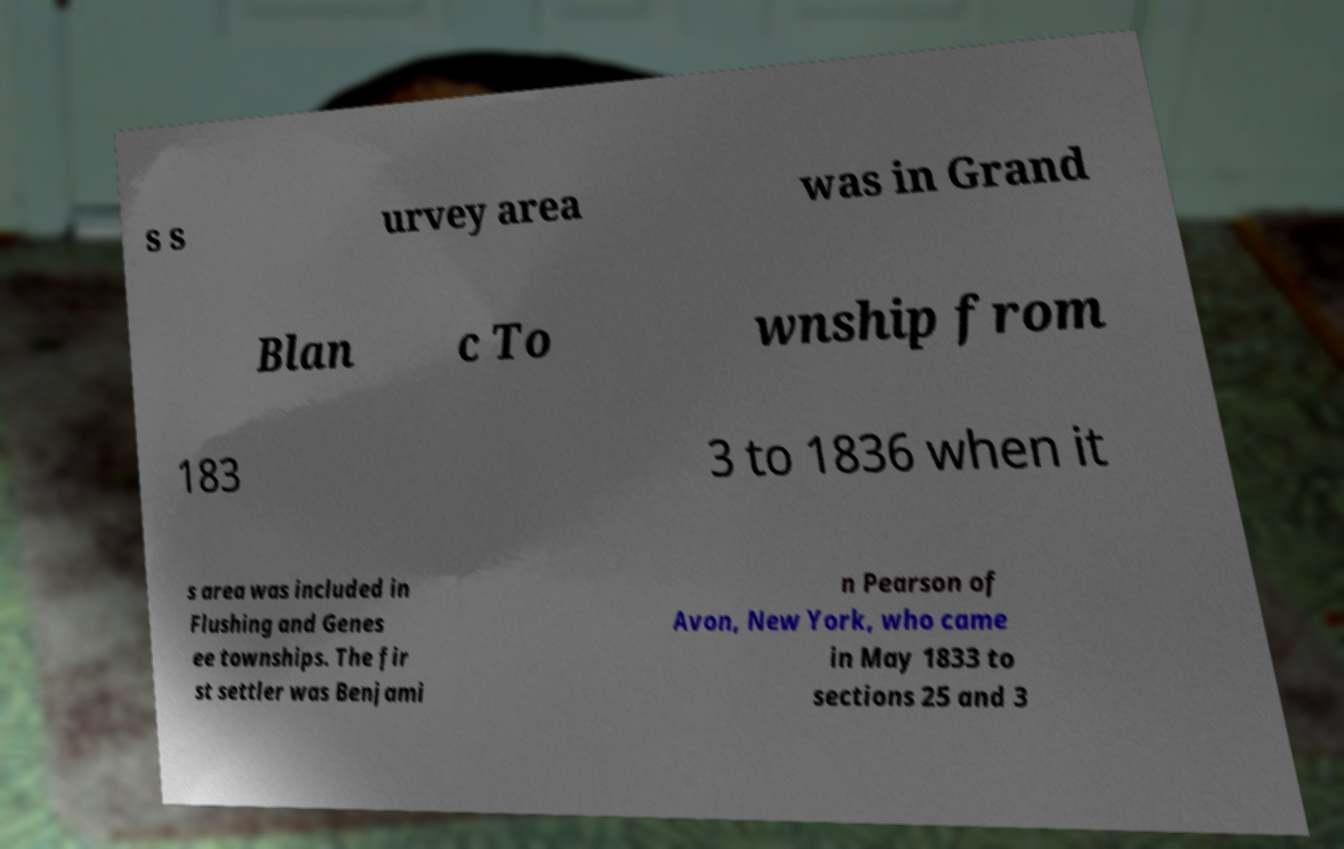Can you read and provide the text displayed in the image?This photo seems to have some interesting text. Can you extract and type it out for me? s s urvey area was in Grand Blan c To wnship from 183 3 to 1836 when it s area was included in Flushing and Genes ee townships. The fir st settler was Benjami n Pearson of Avon, New York, who came in May 1833 to sections 25 and 3 